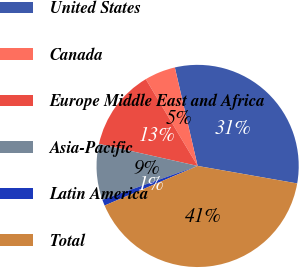<chart> <loc_0><loc_0><loc_500><loc_500><pie_chart><fcel>United States<fcel>Canada<fcel>Europe Middle East and Africa<fcel>Asia-Pacific<fcel>Latin America<fcel>Total<nl><fcel>31.39%<fcel>4.95%<fcel>12.93%<fcel>8.94%<fcel>0.97%<fcel>40.83%<nl></chart> 